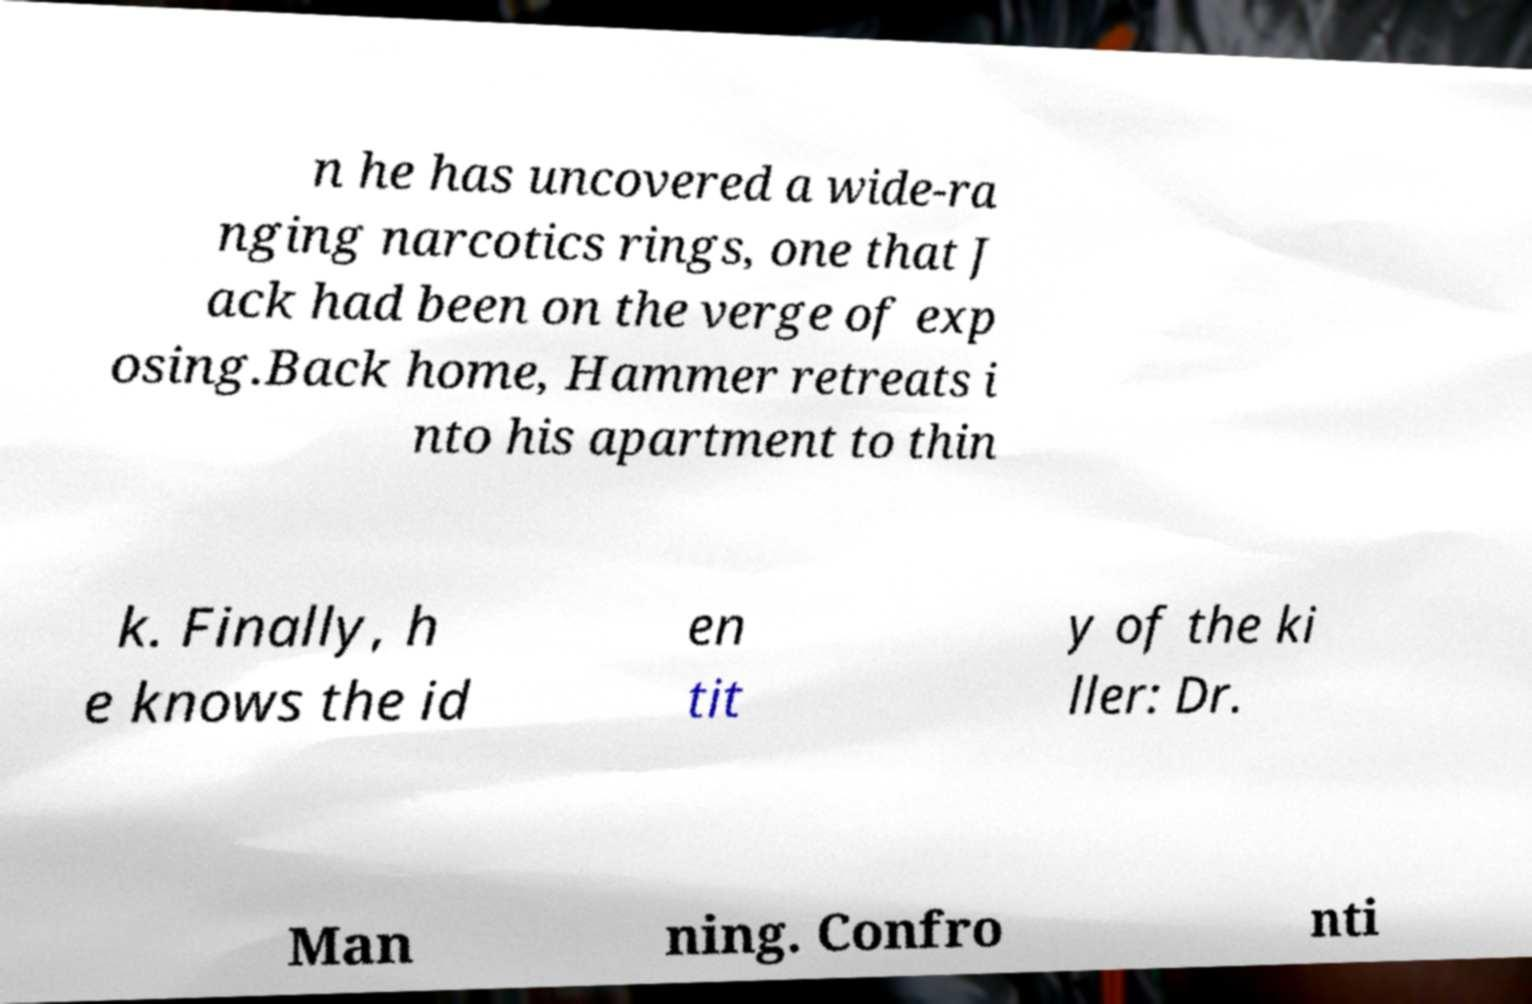Please read and relay the text visible in this image. What does it say? n he has uncovered a wide-ra nging narcotics rings, one that J ack had been on the verge of exp osing.Back home, Hammer retreats i nto his apartment to thin k. Finally, h e knows the id en tit y of the ki ller: Dr. Man ning. Confro nti 